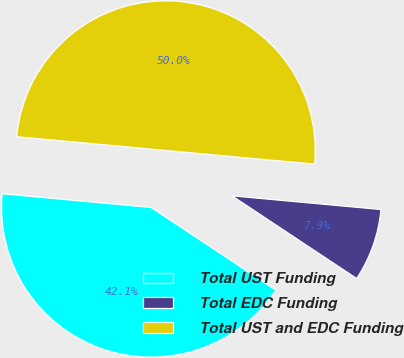Convert chart to OTSL. <chart><loc_0><loc_0><loc_500><loc_500><pie_chart><fcel>Total UST Funding<fcel>Total EDC Funding<fcel>Total UST and EDC Funding<nl><fcel>42.14%<fcel>7.86%<fcel>50.0%<nl></chart> 